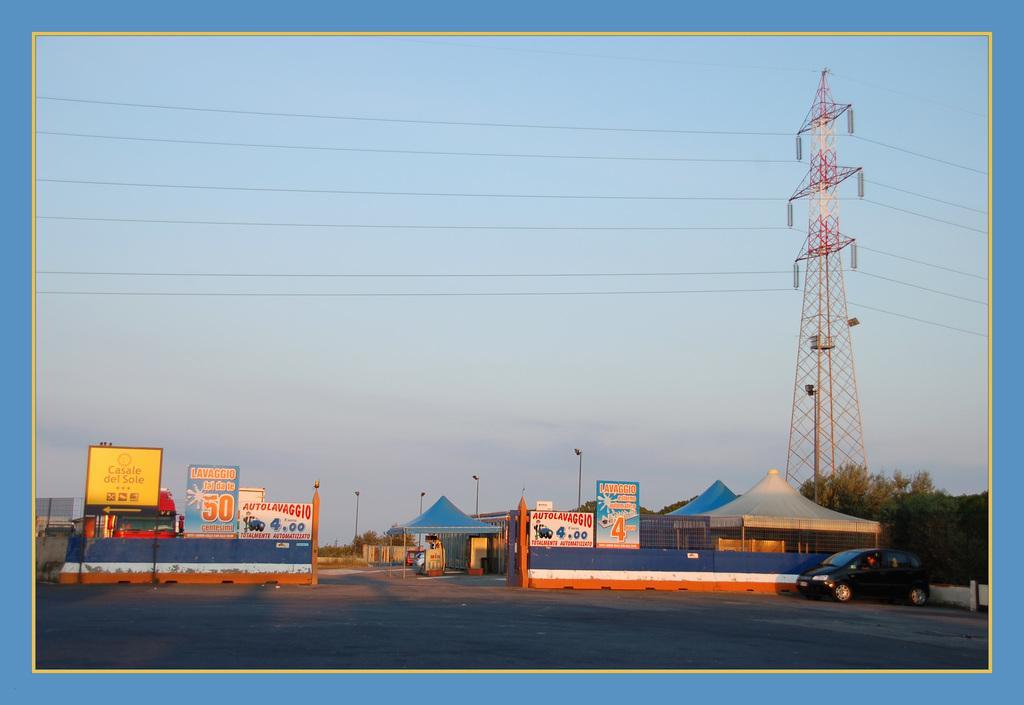Could you give a brief overview of what you see in this image? This is an edited image. At the bottom there is a road. Beside the road there are many buildings, trees and light poles. On the right side there is a car and a transformer along with the wires. On the left side there are few boards on which I can see the text and there are few tents. At the top of the image I can see the sky. 